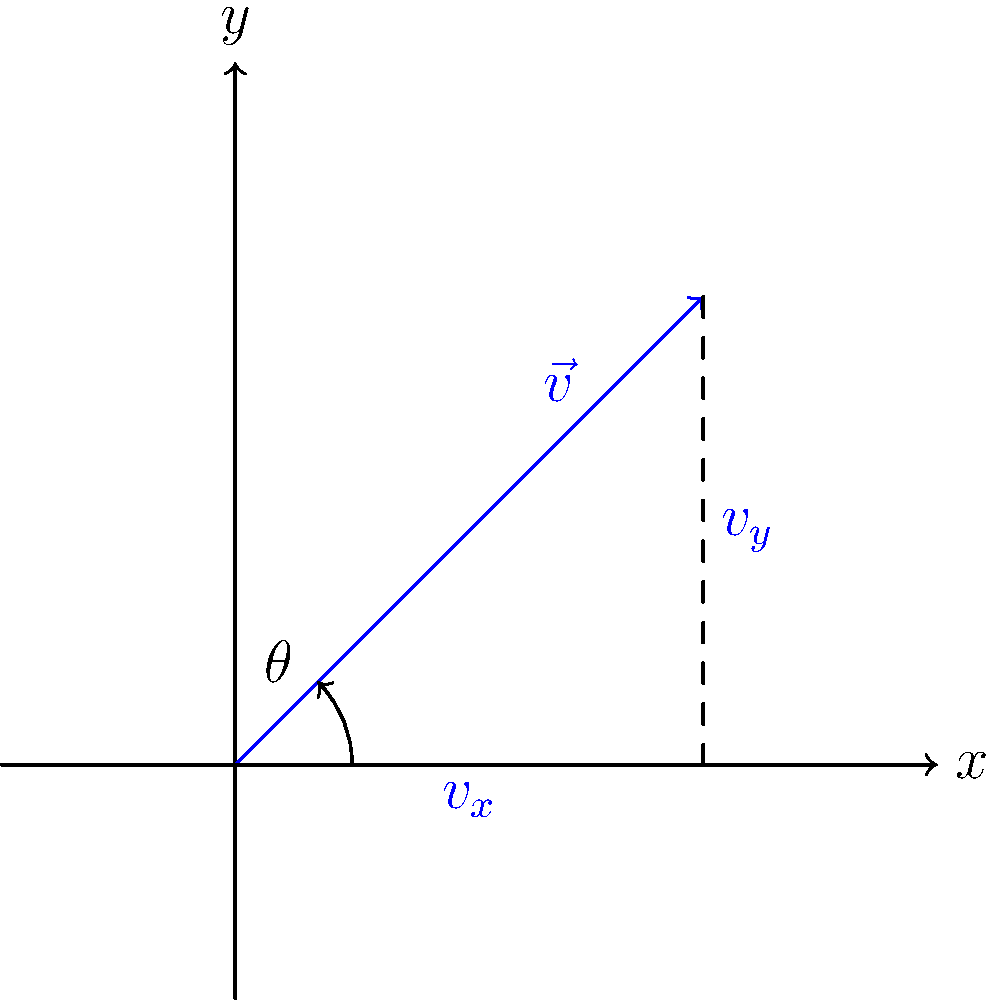In a basketball game, a player applies a spin to the ball, resulting in a rotational velocity vector $\vec{v}$ as shown in the diagram. If the magnitude of the velocity vector is 5 m/s and it makes an angle $\theta = 45°$ with the horizontal, what is the magnitude of the vertical component of the rotational velocity ($v_y$)? To solve this problem, we'll follow these steps:

1. Recall the trigonometric relationship for right triangles:
   In a right triangle, $\sin \theta = \frac{\text{opposite}}{\text{hypotenuse}}$

2. In this case:
   - The hypotenuse is the magnitude of the velocity vector $|\vec{v}| = 5$ m/s
   - The angle $\theta = 45°$
   - We're looking for the vertical component $v_y$, which is the side opposite to the angle $\theta$

3. We can express this relationship as:
   $\sin 45° = \frac{v_y}{5}$

4. Solve for $v_y$:
   $v_y = 5 \sin 45°$

5. Calculate the result:
   $v_y = 5 \cdot \frac{\sqrt{2}}{2} \approx 3.54$ m/s

Therefore, the magnitude of the vertical component of the rotational velocity is approximately 3.54 m/s.
Answer: $3.54$ m/s 